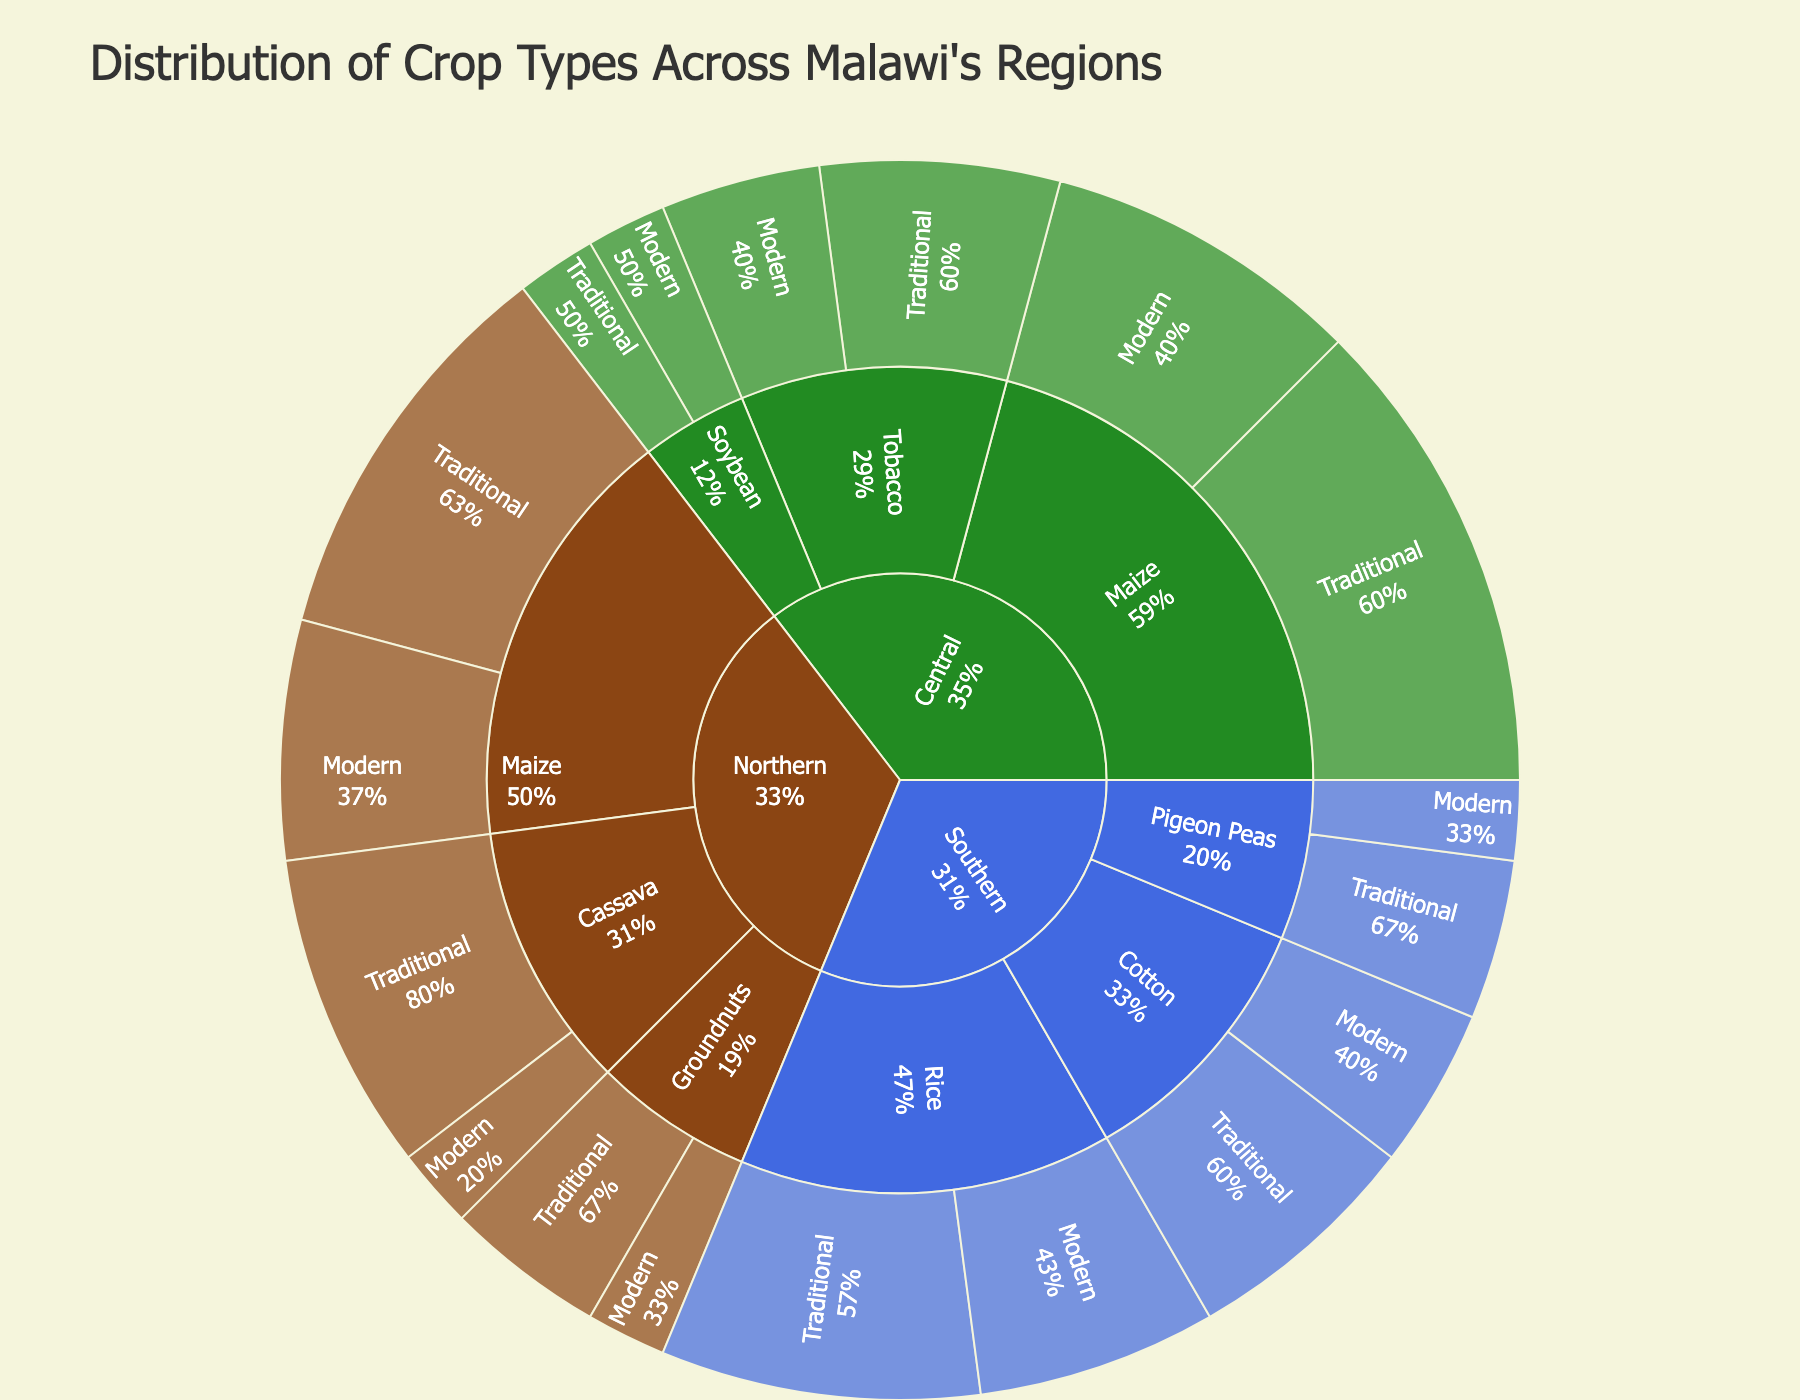what is the title of the sunburst plot? The title is usually displayed at the top of the plot and gives an overall idea of what the plot represents. In this case, we can see it reads "Distribution of Crop Types Across Malawi's Regions."
Answer: Distribution of Crop Types Across Malawi's Regions which region has the highest percentage of traditional maize? First, locate the "Maize" crop type and then find the corresponding "Traditional" percentage in each region. The Central region has the highest percentage at 30%.
Answer: Central region what is the combined percentage of traditional and modern cassava in the northern region? Add the percentages of traditional and modern cassava in the northern region: 20% (traditional) + 5% (modern) = 25%.
Answer: 25% how does the percentage of modern soybean in the central region compare to traditional soybean in the same region? Compare the values: both modern and traditional soybeans in the central region have the same percentage, which is 5%.
Answer: They are equal which crop type is only present in the southern region but not in northern or central regions? Scan the crop types in each region: "Rice" is present only in the southern region.
Answer: Rice what percentage of maize (traditional and modern) is grown in the northern and central regions combined? Sum the percentages of both traditional and modern maize in northern and central regions: (25% + 15%) for Northern + (30% + 20%) for Central = 45% + 50% = 95%.
Answer: 95% what percentage of crops in the southern region are modern varieties? Calculate the sum of modern varieties for rice, cotton, and pigeon peas in the southern region: 15% (rice) + 10% (cotton) + 5% (pigeon peas) = 30%.
Answer: 30% which region has a more diverse set of crop types? Identify the number of different crop types in each region: Northern (3 types: Maize, Cassava, Groundnuts), Central (3 types: Maize, Tobacco, Soybean), and Southern (3 types: Rice, Cotton, Pigeon Peas). All regions have 3 different crop types.
Answer: All regions have equal diversity what is the percentage difference between traditional tobacco and modern tobacco in the central region? Subtract the modern percentage from the traditional percentage for tobacco in the central region: 15% - 10% = 5%.
Answer: 5% which crop type has a higher percentage of traditional varieties in the southern region: rice or cotton? Compare the percentages of traditional rice and traditional cotton in the southern region: traditional rice is 20% and traditional cotton is 15%.
Answer: Rice 